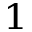<formula> <loc_0><loc_0><loc_500><loc_500>_ { 1 }</formula> 